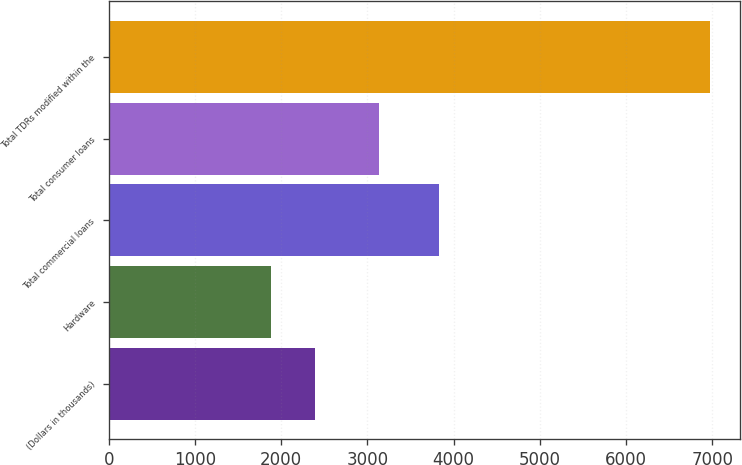Convert chart to OTSL. <chart><loc_0><loc_0><loc_500><loc_500><bar_chart><fcel>(Dollars in thousands)<fcel>Hardware<fcel>Total commercial loans<fcel>Total consumer loans<fcel>Total TDRs modified within the<nl><fcel>2393.2<fcel>1885<fcel>3834<fcel>3133<fcel>6967<nl></chart> 